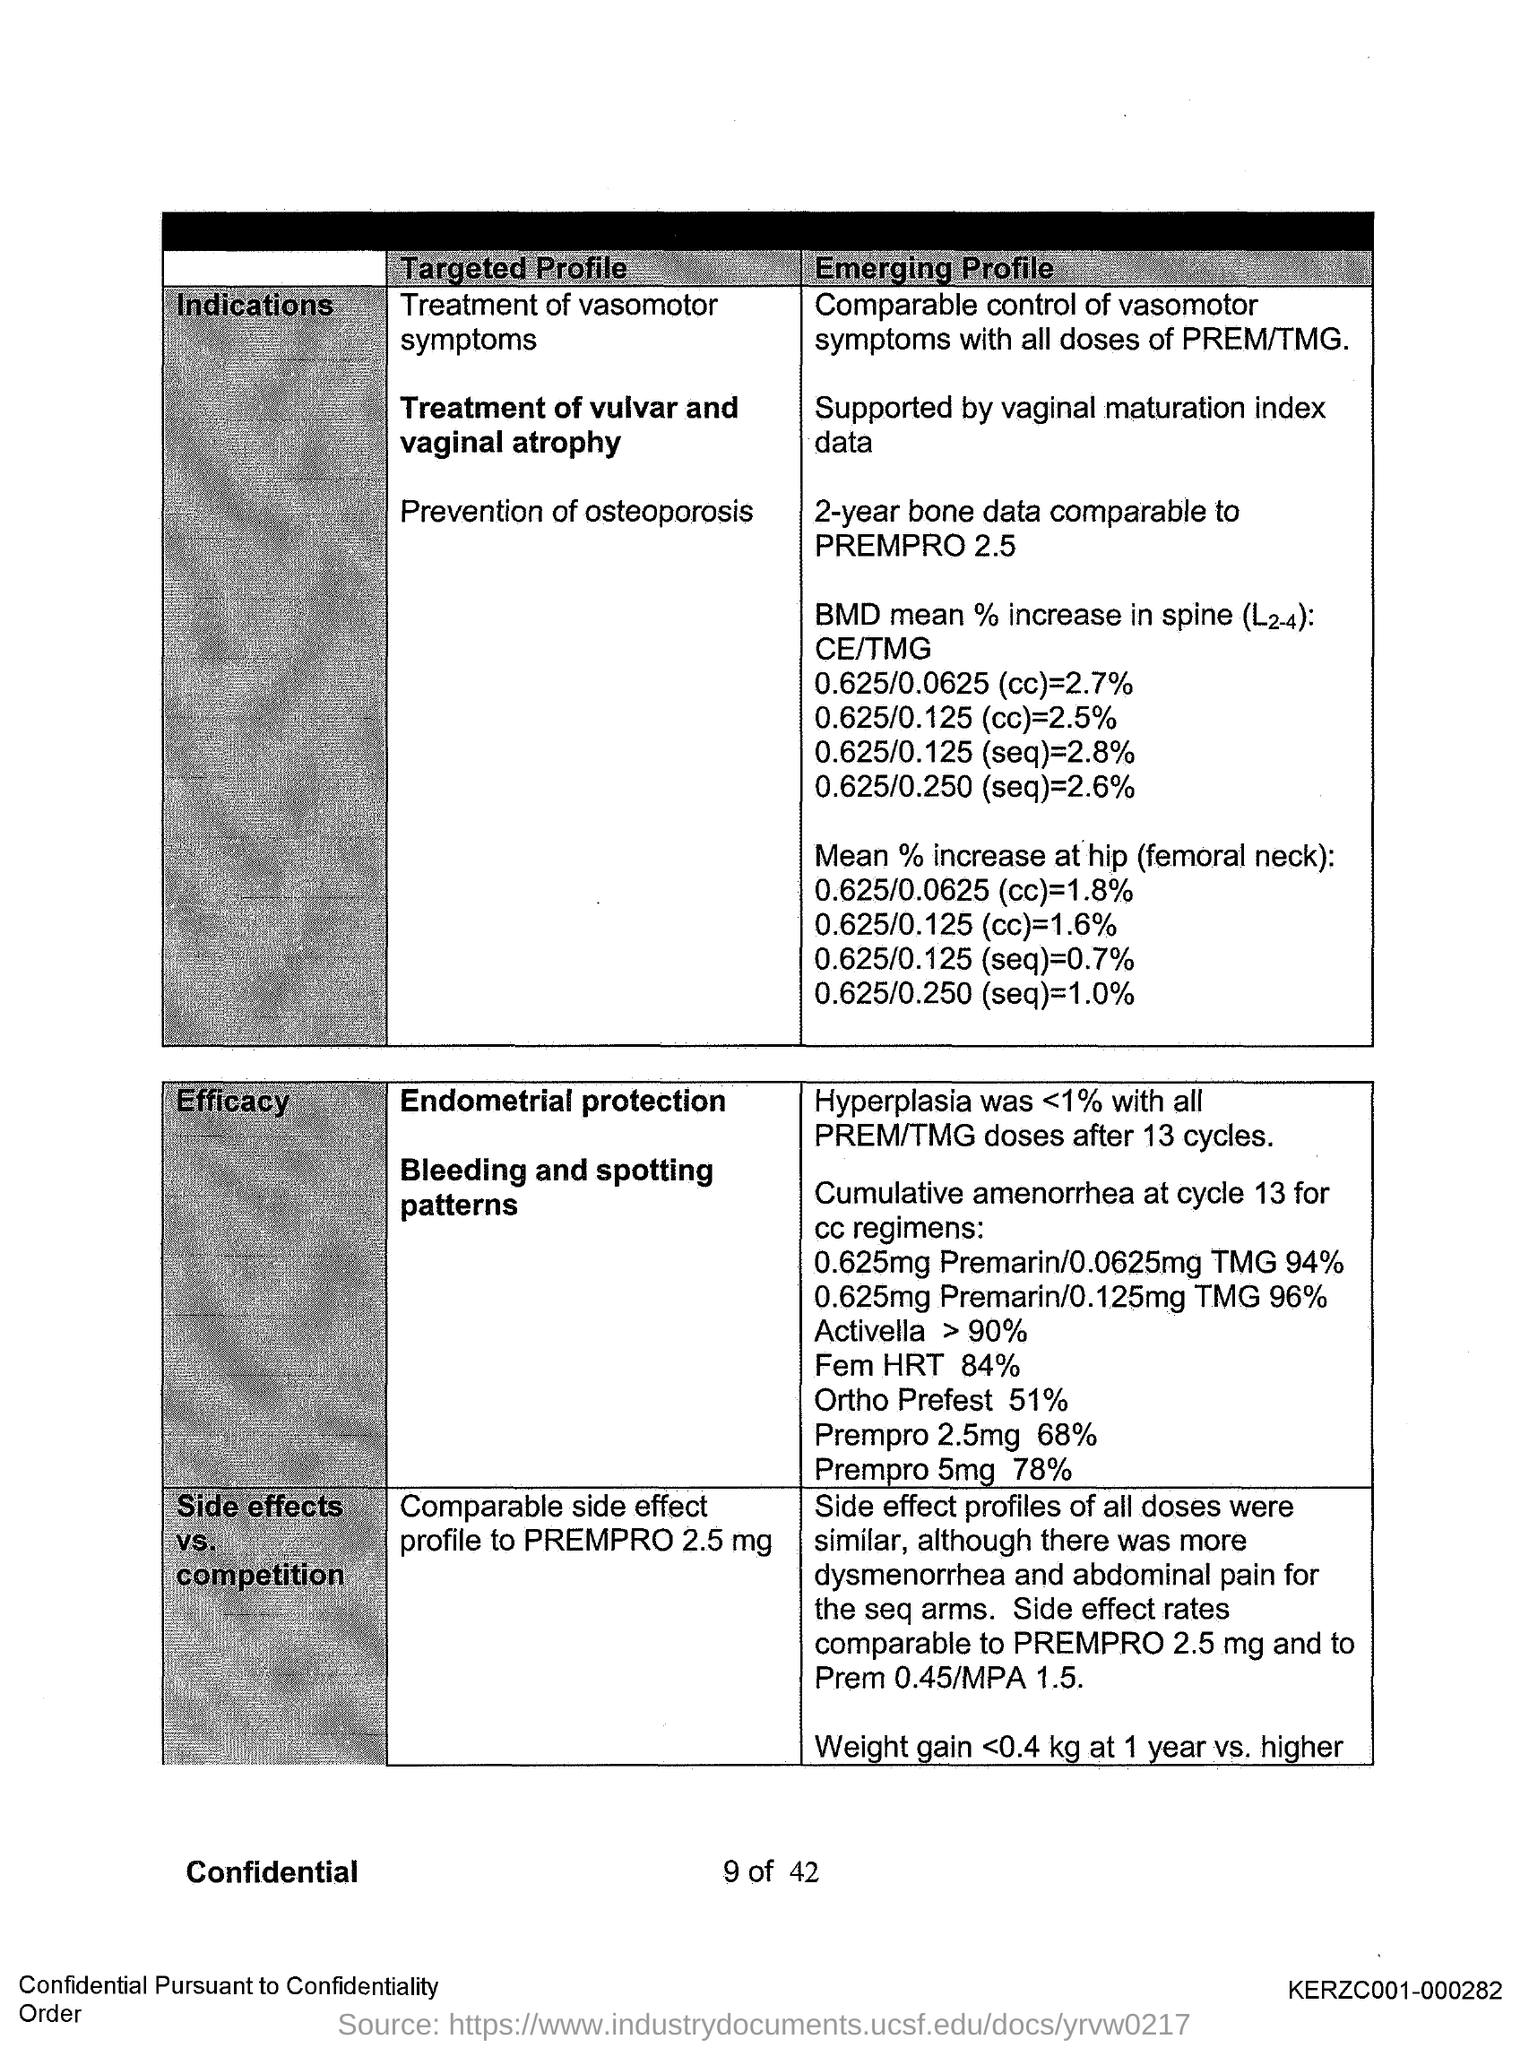What is the "Mean % increase at hip (femoral neck):0.625/0.0625 (cc)"?
Offer a terse response. 1.8%. What is the "Mean % increase at hip (femoral neck):0.625/0.250 (seq)"?
Keep it short and to the point. 1.0%. How was "Hyperplasia" with all PREM/TMG doses after 13 cycles?
Ensure brevity in your answer.  <1%. Cumulative amenorrhea at which cycle is taken for cc regimens?
Your response must be concise. Cycle 13. What code number is written on right bottom side of the page?
Offer a very short reply. KERZC001-000282. What heading is given for second column of first table?
Provide a short and direct response. Targeted profile. What heading is given for  third column of first table?
Make the answer very short. Emerging Profile. What is the "Mean % increase at hip (femoral neck):0.625/0.125 (seq)"?
Provide a succinct answer. 0.7%. What is the "Mean % increase at hip (femoral neck):0.625/0.125 (cc)"?
Your answer should be compact. 1.6%. 